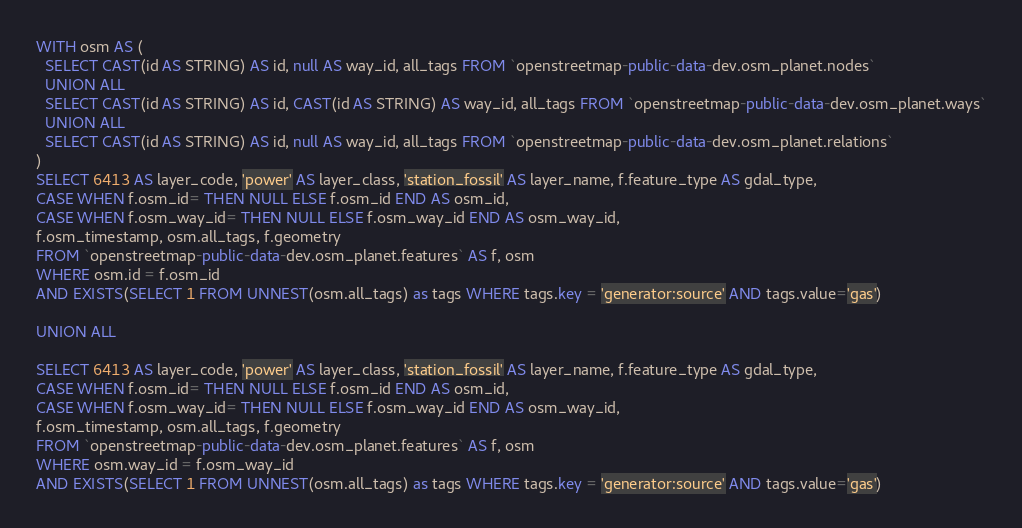Convert code to text. <code><loc_0><loc_0><loc_500><loc_500><_SQL_>
WITH osm AS (
  SELECT CAST(id AS STRING) AS id, null AS way_id, all_tags FROM `openstreetmap-public-data-dev.osm_planet.nodes`
  UNION ALL
  SELECT CAST(id AS STRING) AS id, CAST(id AS STRING) AS way_id, all_tags FROM `openstreetmap-public-data-dev.osm_planet.ways`
  UNION ALL
  SELECT CAST(id AS STRING) AS id, null AS way_id, all_tags FROM `openstreetmap-public-data-dev.osm_planet.relations`
)
SELECT 6413 AS layer_code, 'power' AS layer_class, 'station_fossil' AS layer_name, f.feature_type AS gdal_type,
CASE WHEN f.osm_id= THEN NULL ELSE f.osm_id END AS osm_id,
CASE WHEN f.osm_way_id= THEN NULL ELSE f.osm_way_id END AS osm_way_id,
f.osm_timestamp, osm.all_tags, f.geometry
FROM `openstreetmap-public-data-dev.osm_planet.features` AS f, osm
WHERE osm.id = f.osm_id
AND EXISTS(SELECT 1 FROM UNNEST(osm.all_tags) as tags WHERE tags.key = 'generator:source' AND tags.value='gas')

UNION ALL

SELECT 6413 AS layer_code, 'power' AS layer_class, 'station_fossil' AS layer_name, f.feature_type AS gdal_type,
CASE WHEN f.osm_id= THEN NULL ELSE f.osm_id END AS osm_id,
CASE WHEN f.osm_way_id= THEN NULL ELSE f.osm_way_id END AS osm_way_id,
f.osm_timestamp, osm.all_tags, f.geometry
FROM `openstreetmap-public-data-dev.osm_planet.features` AS f, osm
WHERE osm.way_id = f.osm_way_id
AND EXISTS(SELECT 1 FROM UNNEST(osm.all_tags) as tags WHERE tags.key = 'generator:source' AND tags.value='gas')

</code> 